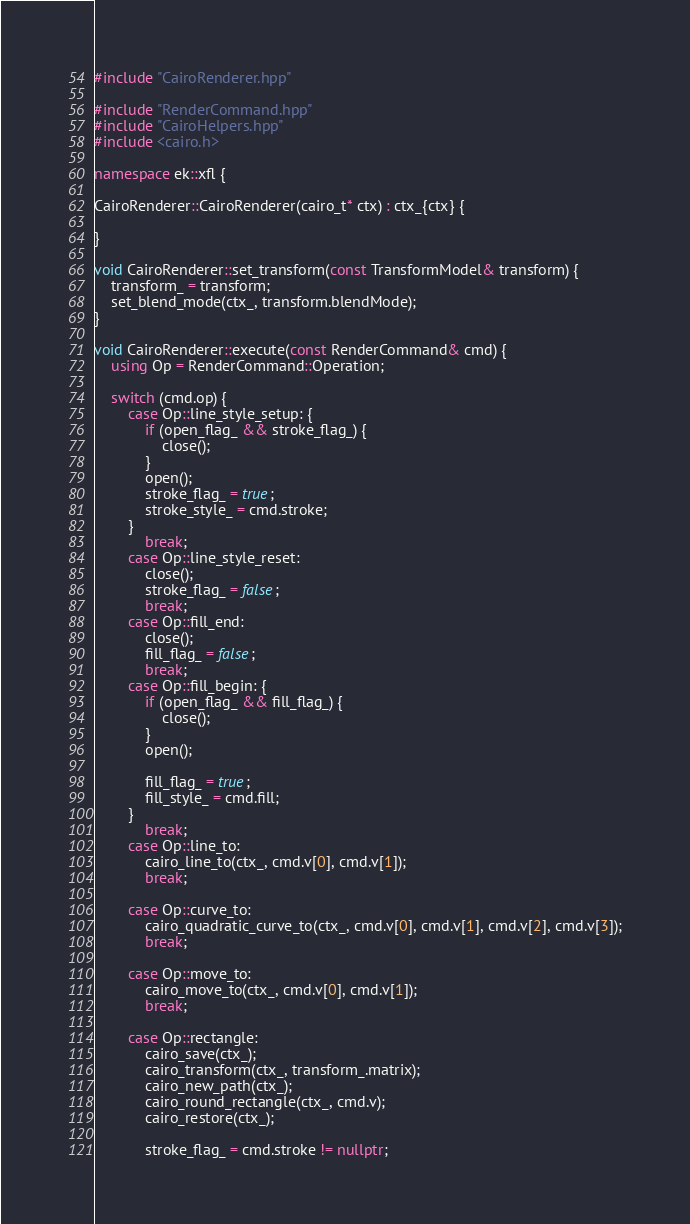<code> <loc_0><loc_0><loc_500><loc_500><_C++_>#include "CairoRenderer.hpp"

#include "RenderCommand.hpp"
#include "CairoHelpers.hpp"
#include <cairo.h>

namespace ek::xfl {

CairoRenderer::CairoRenderer(cairo_t* ctx) : ctx_{ctx} {

}

void CairoRenderer::set_transform(const TransformModel& transform) {
    transform_ = transform;
    set_blend_mode(ctx_, transform.blendMode);
}

void CairoRenderer::execute(const RenderCommand& cmd) {
    using Op = RenderCommand::Operation;

    switch (cmd.op) {
        case Op::line_style_setup: {
            if (open_flag_ && stroke_flag_) {
                close();
            }
            open();
            stroke_flag_ = true;
            stroke_style_ = cmd.stroke;
        }
            break;
        case Op::line_style_reset:
            close();
            stroke_flag_ = false;
            break;
        case Op::fill_end:
            close();
            fill_flag_ = false;
            break;
        case Op::fill_begin: {
            if (open_flag_ && fill_flag_) {
                close();
            }
            open();

            fill_flag_ = true;
            fill_style_ = cmd.fill;
        }
            break;
        case Op::line_to:
            cairo_line_to(ctx_, cmd.v[0], cmd.v[1]);
            break;

        case Op::curve_to:
            cairo_quadratic_curve_to(ctx_, cmd.v[0], cmd.v[1], cmd.v[2], cmd.v[3]);
            break;

        case Op::move_to:
            cairo_move_to(ctx_, cmd.v[0], cmd.v[1]);
            break;

        case Op::rectangle:
            cairo_save(ctx_);
            cairo_transform(ctx_, transform_.matrix);
            cairo_new_path(ctx_);
            cairo_round_rectangle(ctx_, cmd.v);
            cairo_restore(ctx_);

            stroke_flag_ = cmd.stroke != nullptr;</code> 